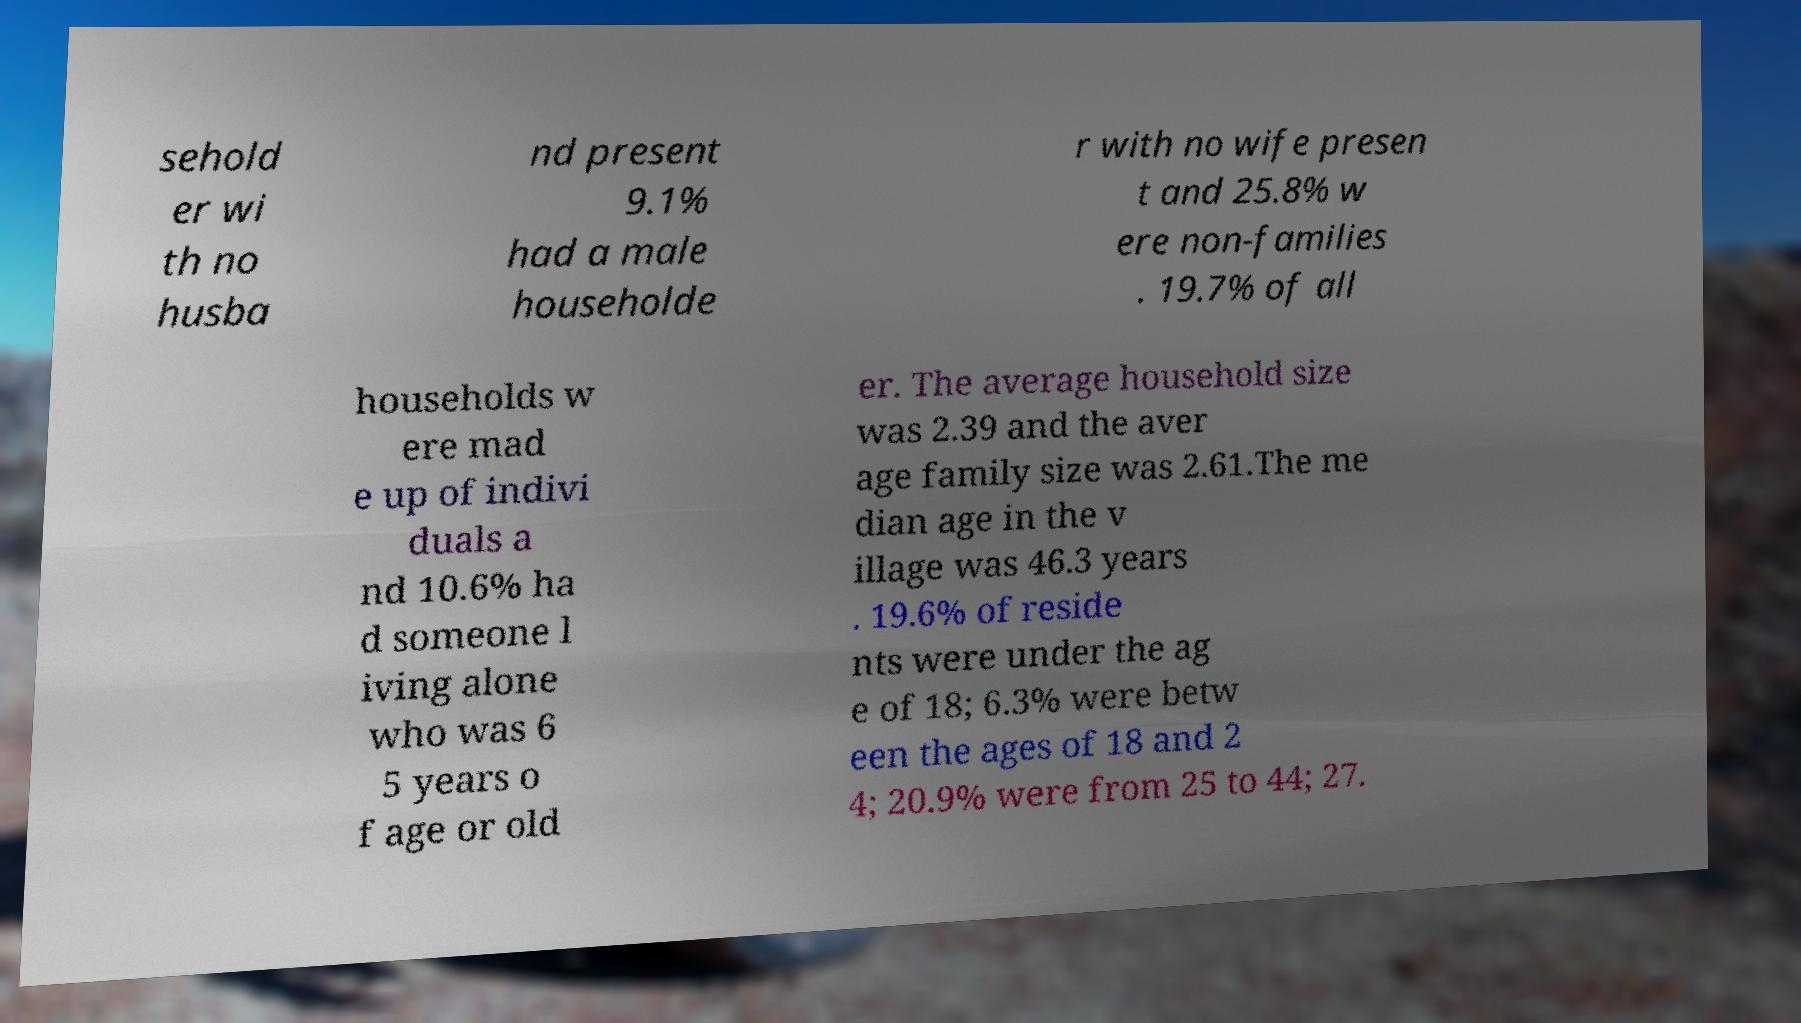What messages or text are displayed in this image? I need them in a readable, typed format. sehold er wi th no husba nd present 9.1% had a male householde r with no wife presen t and 25.8% w ere non-families . 19.7% of all households w ere mad e up of indivi duals a nd 10.6% ha d someone l iving alone who was 6 5 years o f age or old er. The average household size was 2.39 and the aver age family size was 2.61.The me dian age in the v illage was 46.3 years . 19.6% of reside nts were under the ag e of 18; 6.3% were betw een the ages of 18 and 2 4; 20.9% were from 25 to 44; 27. 